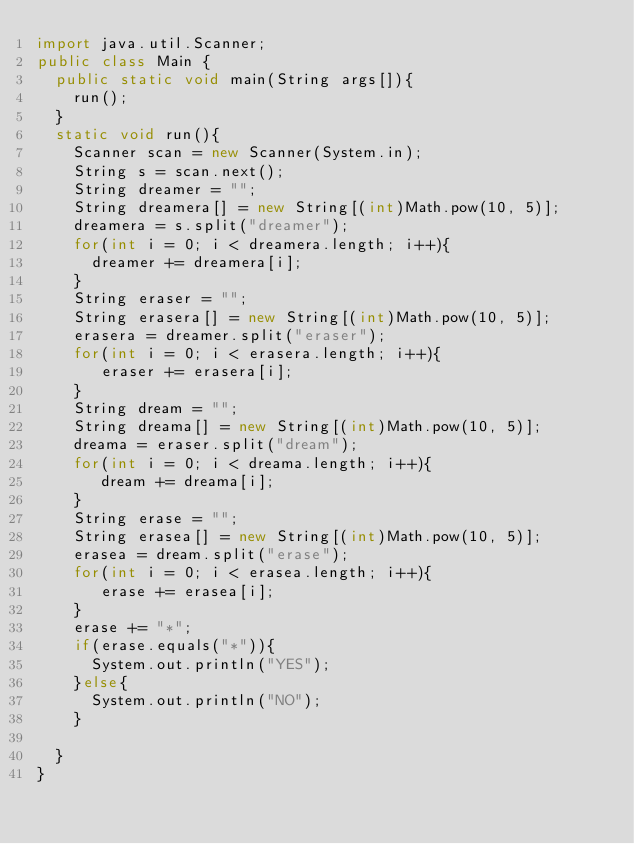Convert code to text. <code><loc_0><loc_0><loc_500><loc_500><_Java_>import java.util.Scanner;
public class Main {
	public static void main(String args[]){
		run();
	}
	static void run(){
		Scanner scan = new Scanner(System.in);
		String s = scan.next();
		String dreamer = "";
		String dreamera[] = new String[(int)Math.pow(10, 5)];
		dreamera = s.split("dreamer");
		for(int i = 0; i < dreamera.length; i++){
			dreamer += dreamera[i];
		}
		String eraser = "";
		String erasera[] = new String[(int)Math.pow(10, 5)];
		erasera = dreamer.split("eraser");
		for(int i = 0; i < erasera.length; i++){
			 eraser += erasera[i];
		}
		String dream = "";
		String dreama[] = new String[(int)Math.pow(10, 5)];
		dreama = eraser.split("dream");
		for(int i = 0; i < dreama.length; i++){
			 dream += dreama[i];
		}
		String erase = "";
		String erasea[] = new String[(int)Math.pow(10, 5)];
		erasea = dream.split("erase");
		for(int i = 0; i < erasea.length; i++){
			 erase += erasea[i];
		}
		erase += "*";
		if(erase.equals("*")){
			System.out.println("YES");
		}else{
			System.out.println("NO");
		}
		
	}
}
</code> 